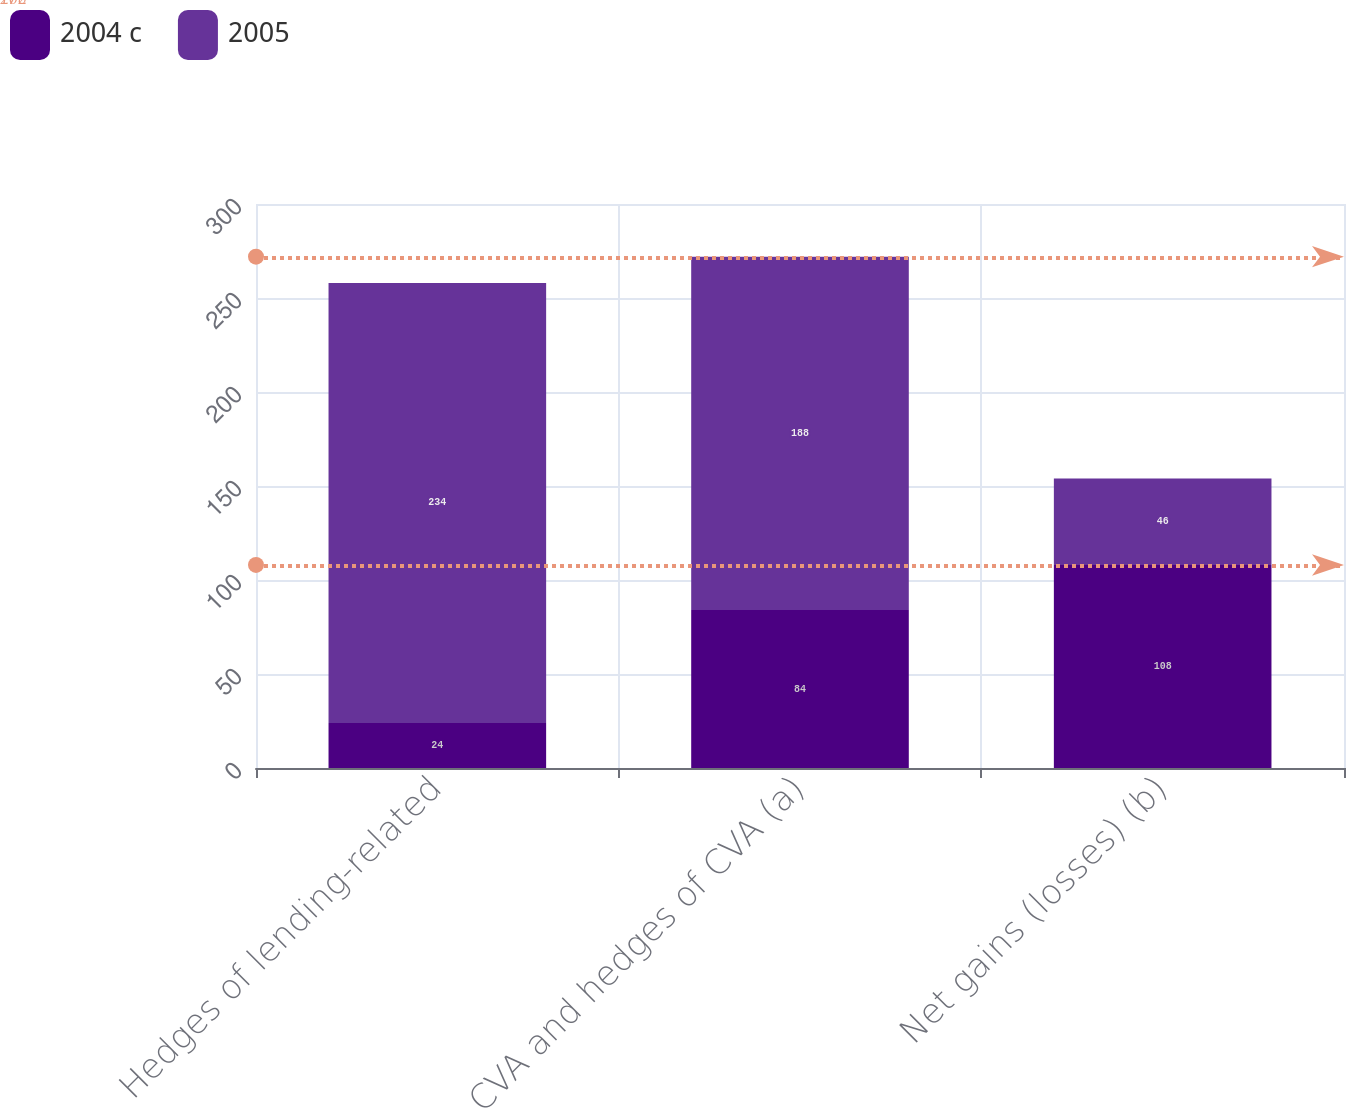<chart> <loc_0><loc_0><loc_500><loc_500><stacked_bar_chart><ecel><fcel>Hedges of lending-related<fcel>CVA and hedges of CVA (a)<fcel>Net gains (losses) (b)<nl><fcel>2004 c<fcel>24<fcel>84<fcel>108<nl><fcel>2005<fcel>234<fcel>188<fcel>46<nl></chart> 